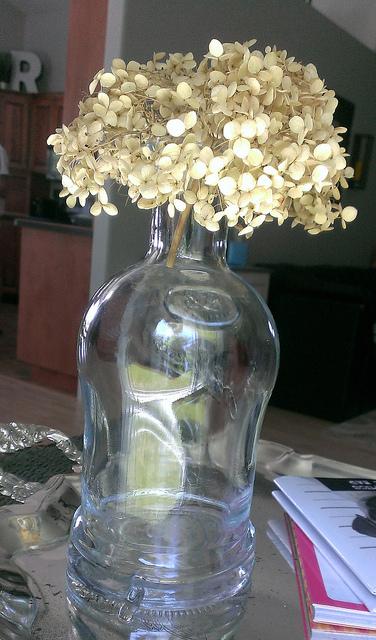Where are the flowers?
Concise answer only. Vase. What is the pink object?
Be succinct. Book. Is the vase transparent?
Concise answer only. Yes. 